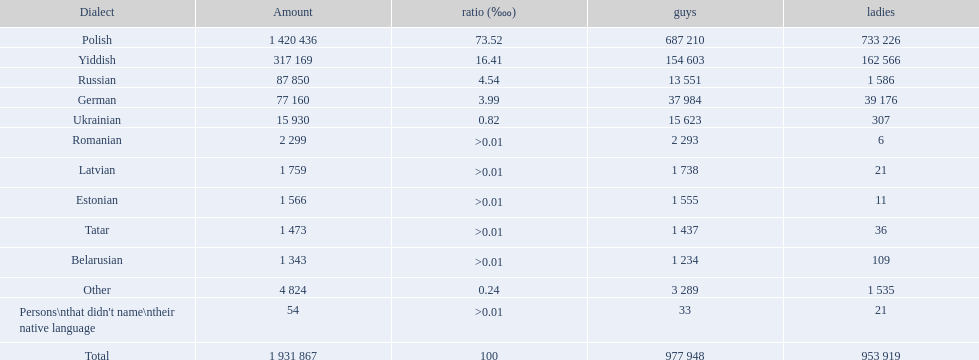What named native languages spoken in the warsaw governorate have more males then females? Russian, Ukrainian, Romanian, Latvian, Estonian, Tatar, Belarusian. Which of those have less then 500 males listed? Romanian, Latvian, Estonian, Tatar, Belarusian. Of the remaining languages which of them have less then 20 females? Romanian, Estonian. Which of these has the highest total number listed? Romanian. 